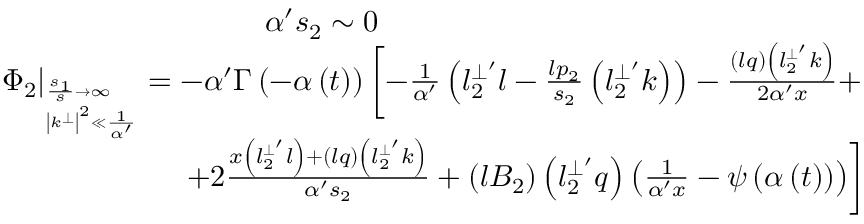<formula> <loc_0><loc_0><loc_500><loc_500>\begin{array} { r } { { \alpha ^ { \prime } s _ { 2 } \sim 0 \quad } } \\ { { \Phi _ { 2 } \right | _ { _ { \left | k ^ { \bot } \right | ^ { 2 } \ll \frac { 1 } \alpha ^ { \prime } } } ^ { \frac { s _ { 1 } } s \rightarrow \infty } } = - \alpha ^ { \prime } \Gamma \left ( - \alpha \left ( t \right ) \right ) \left [ - \frac { 1 } \alpha ^ { \prime } } \left ( l _ { 2 } ^ { \bot ^ { \prime } } l - \frac { l p _ { 2 } } { s _ { 2 } } \left ( l _ { 2 } ^ { \bot ^ { \prime } } k \right ) \right ) - \frac { \left ( l q \right ) \left ( l _ { 2 } ^ { \bot ^ { \prime } } k \right ) } { 2 \alpha ^ { \prime } x } + } } \\ { { + 2 \frac { x \left ( l _ { 2 } ^ { \bot ^ { \prime } } l \right ) + \left ( l q \right ) \left ( l _ { 2 } ^ { \bot ^ { \prime } } k \right ) } { \alpha ^ { \prime } s _ { 2 } } + \left ( l B _ { 2 } \right ) \left ( l _ { 2 } ^ { \bot ^ { \prime } } q \right ) \left ( \frac { 1 } \alpha ^ { \prime } x } - \psi \left ( \alpha \left ( t \right ) \right ) \right ) \right ] } } \end{array}</formula> 